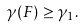Convert formula to latex. <formula><loc_0><loc_0><loc_500><loc_500>\gamma ( F ) \geq \gamma _ { 1 } .</formula> 